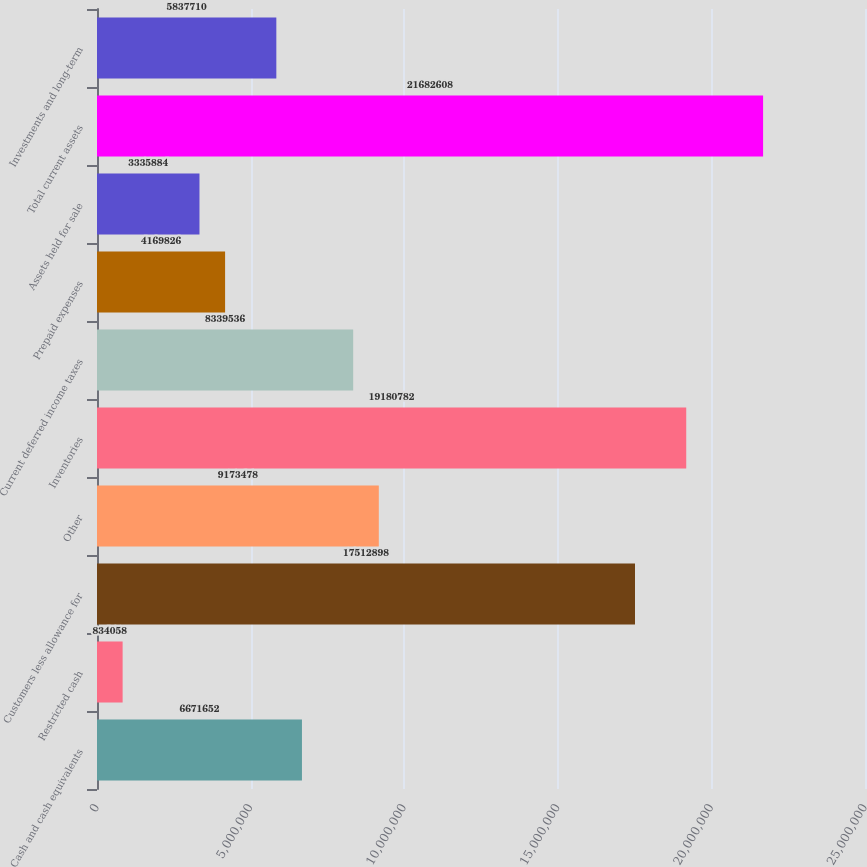<chart> <loc_0><loc_0><loc_500><loc_500><bar_chart><fcel>Cash and cash equivalents<fcel>Restricted cash<fcel>Customers less allowance for<fcel>Other<fcel>Inventories<fcel>Current deferred income taxes<fcel>Prepaid expenses<fcel>Assets held for sale<fcel>Total current assets<fcel>Investments and long-term<nl><fcel>6.67165e+06<fcel>834058<fcel>1.75129e+07<fcel>9.17348e+06<fcel>1.91808e+07<fcel>8.33954e+06<fcel>4.16983e+06<fcel>3.33588e+06<fcel>2.16826e+07<fcel>5.83771e+06<nl></chart> 